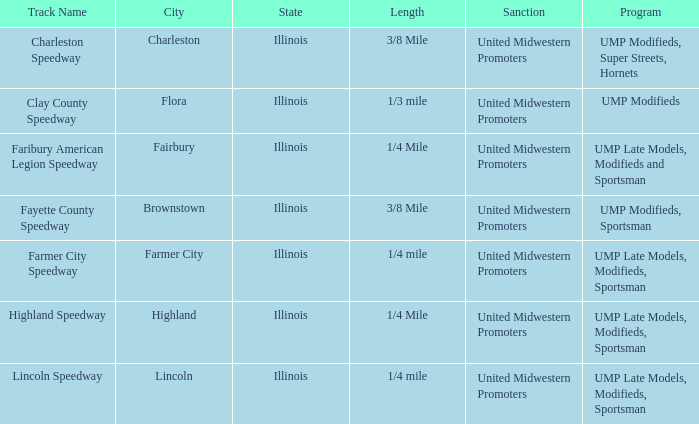Could you parse the entire table? {'header': ['Track Name', 'City', 'State', 'Length', 'Sanction', 'Program'], 'rows': [['Charleston Speedway', 'Charleston', 'Illinois', '3/8 Mile', 'United Midwestern Promoters', 'UMP Modifieds, Super Streets, Hornets'], ['Clay County Speedway', 'Flora', 'Illinois', '1/3 mile', 'United Midwestern Promoters', 'UMP Modifieds'], ['Faribury American Legion Speedway', 'Fairbury', 'Illinois', '1/4 Mile', 'United Midwestern Promoters', 'UMP Late Models, Modifieds and Sportsman'], ['Fayette County Speedway', 'Brownstown', 'Illinois', '3/8 Mile', 'United Midwestern Promoters', 'UMP Modifieds, Sportsman'], ['Farmer City Speedway', 'Farmer City', 'Illinois', '1/4 mile', 'United Midwestern Promoters', 'UMP Late Models, Modifieds, Sportsman'], ['Highland Speedway', 'Highland', 'Illinois', '1/4 Mile', 'United Midwestern Promoters', 'UMP Late Models, Modifieds, Sportsman'], ['Lincoln Speedway', 'Lincoln', 'Illinois', '1/4 mile', 'United Midwestern Promoters', 'UMP Late Models, Modifieds, Sportsman']]} What programs were held at highland speedway? UMP Late Models, Modifieds, Sportsman. 